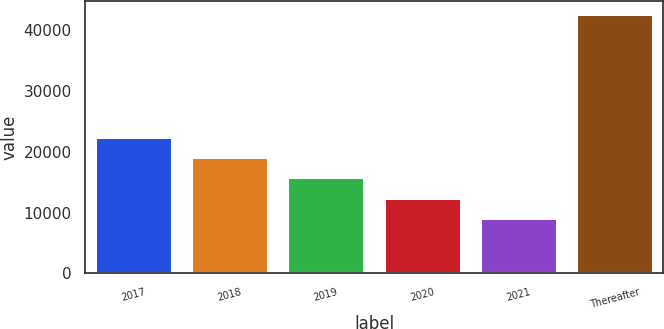Convert chart. <chart><loc_0><loc_0><loc_500><loc_500><bar_chart><fcel>2017<fcel>2018<fcel>2019<fcel>2020<fcel>2021<fcel>Thereafter<nl><fcel>22499.6<fcel>19150.7<fcel>15801.8<fcel>12452.9<fcel>9104<fcel>42593<nl></chart> 